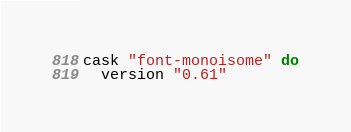<code> <loc_0><loc_0><loc_500><loc_500><_Ruby_>cask "font-monoisome" do
  version "0.61"</code> 